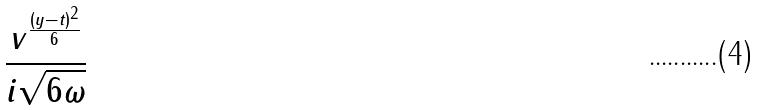<formula> <loc_0><loc_0><loc_500><loc_500>\frac { v ^ { \frac { ( y - t ) ^ { 2 } } { 6 } } } { i \sqrt { 6 \omega } }</formula> 